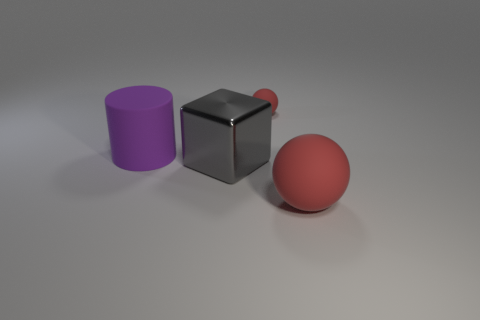How many things are rubber balls or matte objects that are behind the large red ball?
Provide a succinct answer. 3. The large rubber object that is to the left of the red ball that is in front of the matte thing behind the purple object is what color?
Your response must be concise. Purple. There is a red ball that is in front of the metallic object; how big is it?
Your response must be concise. Large. How many big things are yellow shiny spheres or gray shiny blocks?
Provide a succinct answer. 1. The thing that is both in front of the tiny rubber ball and behind the big gray metal cube is what color?
Your answer should be compact. Purple. Are there any big matte things that have the same shape as the small red thing?
Your answer should be compact. Yes. What material is the large purple cylinder?
Make the answer very short. Rubber. There is a big red object; are there any gray things on the right side of it?
Provide a short and direct response. No. Is the shape of the big red rubber thing the same as the tiny red matte object?
Provide a short and direct response. Yes. How many other objects are the same size as the gray object?
Your response must be concise. 2. 